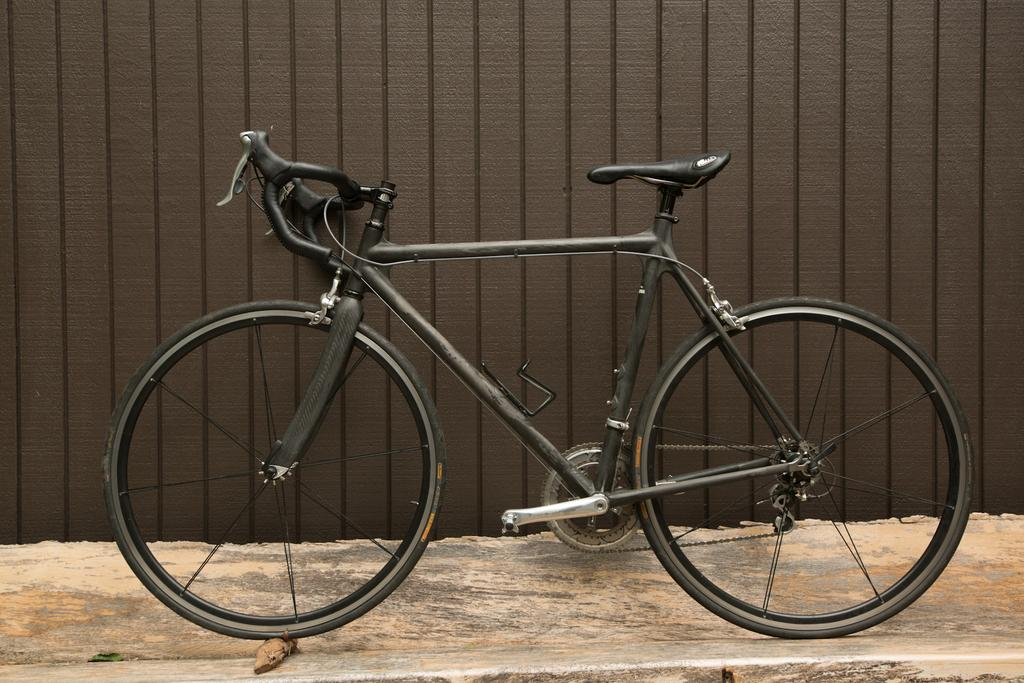What is the main subject of the image? The main subject of the image is a bicycle. Where is the bicycle located in the image? The bicycle is in the center of the image. What type of music can be heard coming from the bicycle in the image? There is no indication in the image that the bicycle is producing any music, so it's not possible to determine what, if any, music might be heard. 